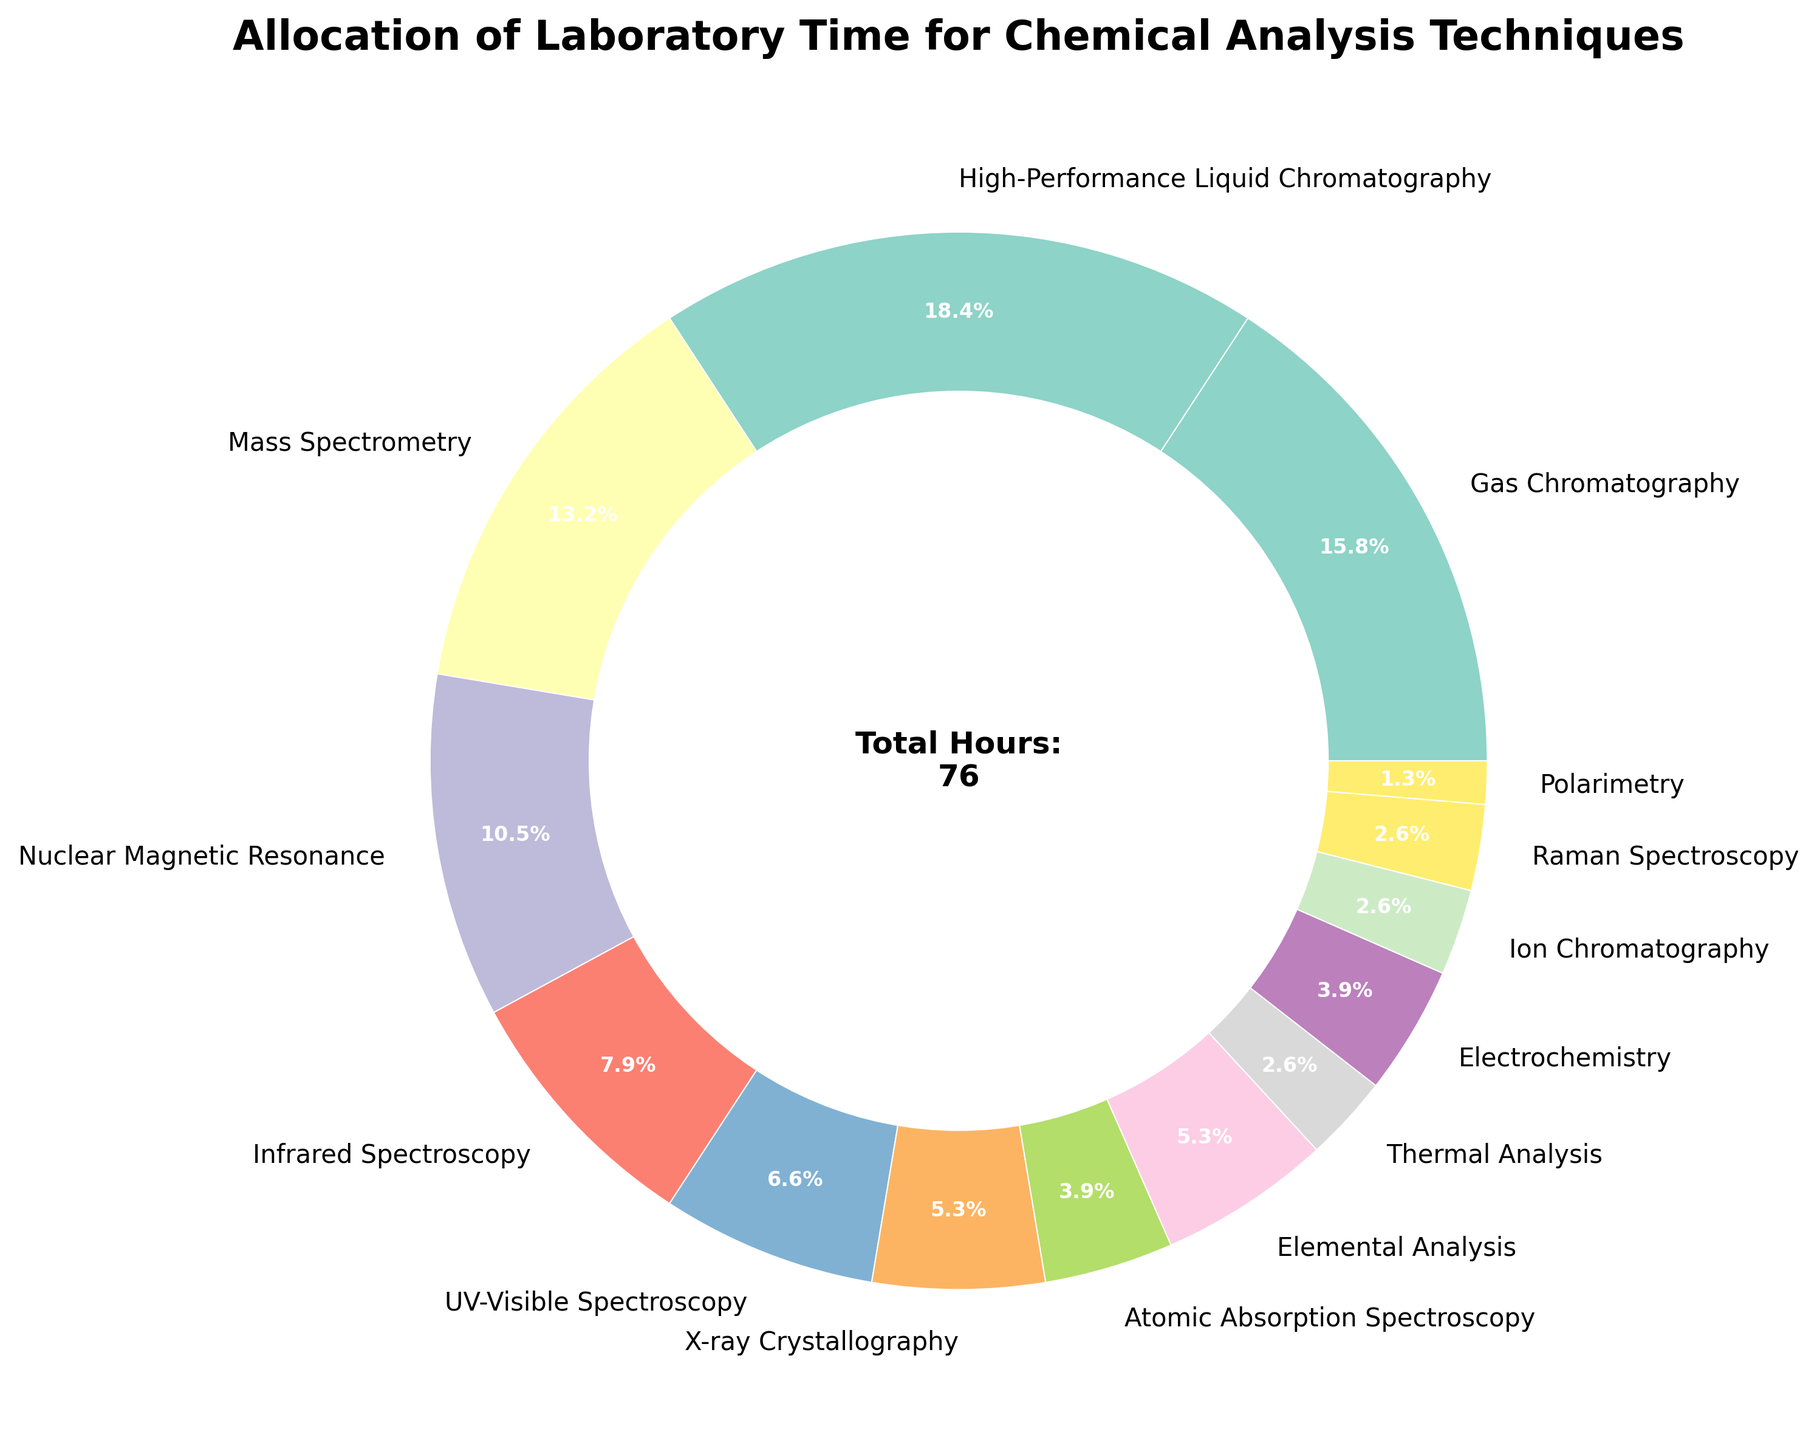What percentage of the laboratory time is allocated to Gas Chromatography? Gas Chromatography is given as 12 hours per week. The total hours are 76. The percentage is (12/76) * 100 ≈ 15.8%.
Answer: 15.8% Which technique has the most allocated laboratory time? By looking at the pie chart, High-Performance Liquid Chromatography has the largest slice, which corresponds to 14 hours per week.
Answer: High-Performance Liquid Chromatography Which techniques have 4 hours of laboratory time allocated to them? The pie chart slices labeled with 4 hours are Elemental Analysis and X-ray Crystallography.
Answer: Elemental Analysis and X-ray Crystallography What is the combined percentage of laboratory time allocated to Nuclear Magnetic Resonance and Mass Spectrometry? NMR is 8 hours and Mass Spectrometry is 10 hours. The total is 18 hours. The percentage of total time is (18/76) * 100 ≈ 23.7%.
Answer: 23.7% How many hours less are allocated to Electrochemistry compared to High-Performance Liquid Chromatography? High-Performance Liquid Chromatography has 14 hours and Electrochemistry has 3 hours. The difference is 14 - 3 = 11 hours.
Answer: 11 hours Which techniques have the smallest allocation of laboratory time? The pie chart shows Polarimetry, Ion Chromatography, and Thermal Analysis each have 2 hours or less, Polarimetry being the smallest with 1 hour.
Answer: Polarimetry How much more laboratory time is allocated to Infrared Spectroscopy compared to UV-Visible Spectroscopy? Infrared Spectroscopy is 6 hours, and UV-Visible Spectroscopy is 5 hours. The difference is 6 - 5 = 1 hour.
Answer: 1 hour What is the total percentage of the laboratory time allocated to techniques with less than 5 hours each? Summing the hours for techniques less than 5 hours: X-ray Crystallography (4), Elemental Analysis (4), Atomic Absorption Spectroscopy (3), Thermal Analysis (2), Electrochemistry (3), Ion Chromatography (2), and Polarimetry (1) gets 19 hours. The percentage is (19/76) * 100 ≈ 25%.
Answer: 25% What is the difference in percentage allocated between the highest and the lowest allocated techniques? High-Performance Liquid Chromatography is 14 hours (18.4%) and Polarimetry is 1 hour (1.3%). The difference is 18.4% - 1.3% = 17.1%.
Answer: 17.1% Which techniques have an equal allocation of laboratory time and what are those times? The chart shows that both Elemental Analysis and X-ray Crystallography have 4 hours each. Ion Chromatography and Raman Spectroscopy each have 2 hours.
Answer: Elemental Analysis and X-ray Crystallography (4 hours), Ion Chromatography and Raman Spectroscopy (2 hours) 